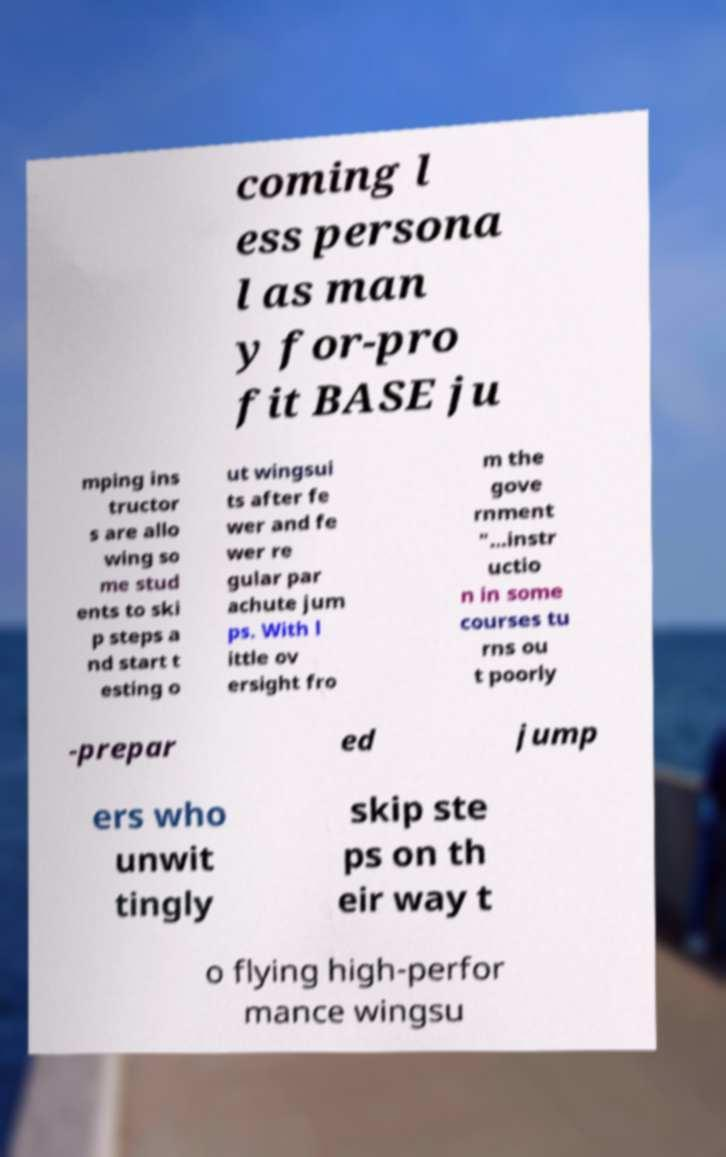Could you assist in decoding the text presented in this image and type it out clearly? coming l ess persona l as man y for-pro fit BASE ju mping ins tructor s are allo wing so me stud ents to ski p steps a nd start t esting o ut wingsui ts after fe wer and fe wer re gular par achute jum ps. With l ittle ov ersight fro m the gove rnment "...instr uctio n in some courses tu rns ou t poorly -prepar ed jump ers who unwit tingly skip ste ps on th eir way t o flying high-perfor mance wingsu 